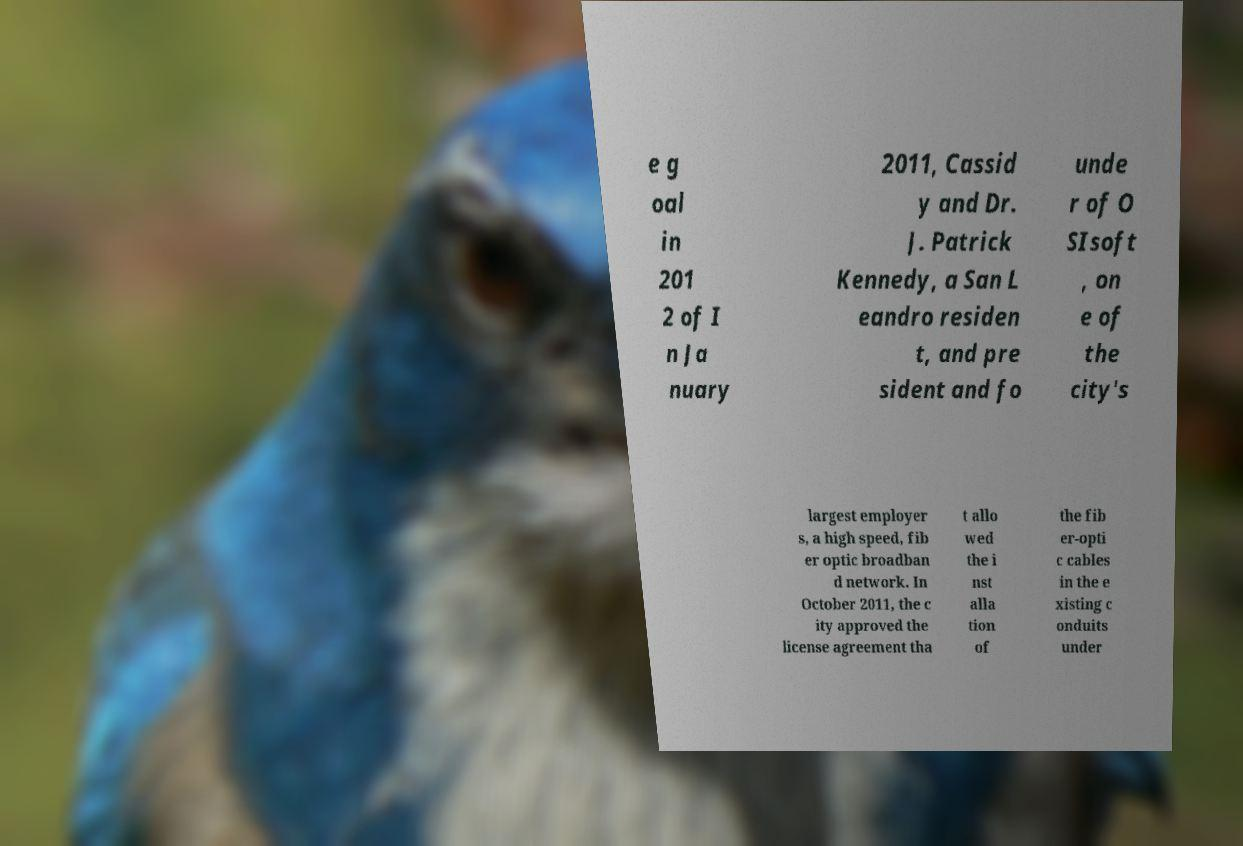There's text embedded in this image that I need extracted. Can you transcribe it verbatim? e g oal in 201 2 of I n Ja nuary 2011, Cassid y and Dr. J. Patrick Kennedy, a San L eandro residen t, and pre sident and fo unde r of O SIsoft , on e of the city's largest employer s, a high speed, fib er optic broadban d network. In October 2011, the c ity approved the license agreement tha t allo wed the i nst alla tion of the fib er-opti c cables in the e xisting c onduits under 